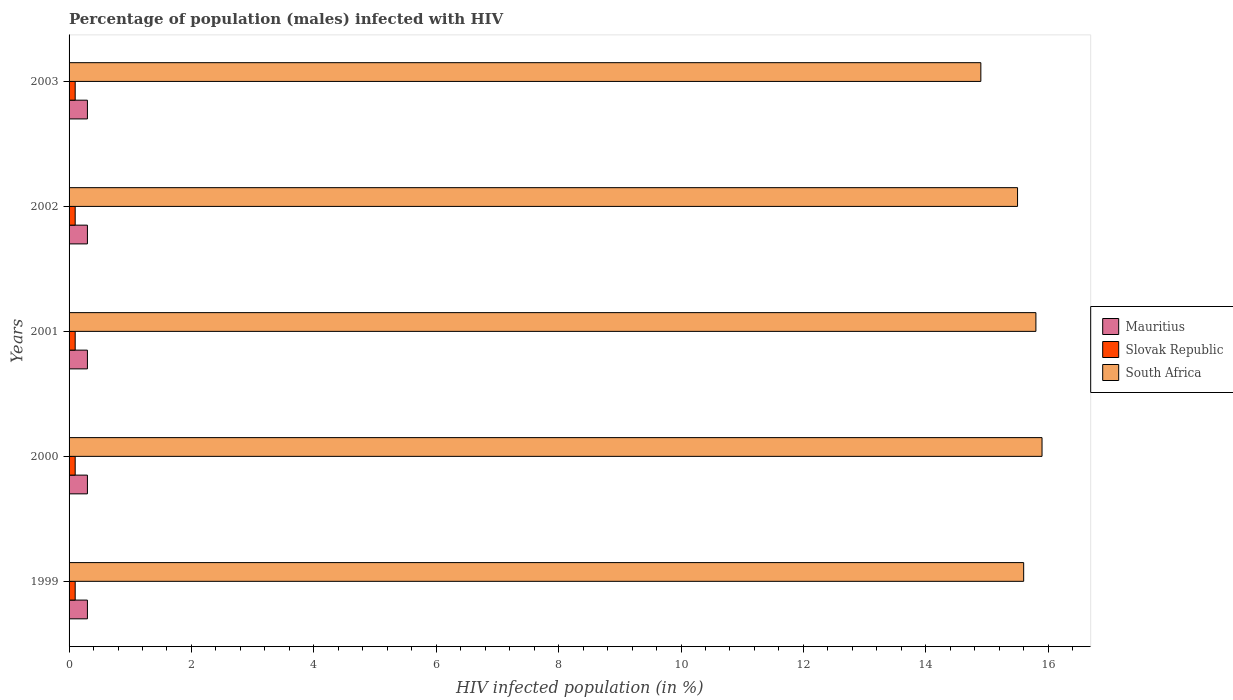Are the number of bars per tick equal to the number of legend labels?
Your answer should be very brief. Yes. What is the label of the 5th group of bars from the top?
Your response must be concise. 1999. What is the percentage of HIV infected male population in Mauritius in 2000?
Give a very brief answer. 0.3. Across all years, what is the maximum percentage of HIV infected male population in Mauritius?
Ensure brevity in your answer.  0.3. Across all years, what is the minimum percentage of HIV infected male population in Mauritius?
Your response must be concise. 0.3. In which year was the percentage of HIV infected male population in Slovak Republic minimum?
Keep it short and to the point. 1999. What is the total percentage of HIV infected male population in South Africa in the graph?
Offer a very short reply. 77.7. What is the difference between the percentage of HIV infected male population in South Africa in 2000 and the percentage of HIV infected male population in Mauritius in 2002?
Give a very brief answer. 15.6. What is the average percentage of HIV infected male population in South Africa per year?
Ensure brevity in your answer.  15.54. In the year 1999, what is the difference between the percentage of HIV infected male population in Slovak Republic and percentage of HIV infected male population in South Africa?
Offer a very short reply. -15.5. What is the ratio of the percentage of HIV infected male population in South Africa in 2000 to that in 2002?
Offer a terse response. 1.03. Is the percentage of HIV infected male population in Mauritius in 1999 less than that in 2001?
Ensure brevity in your answer.  No. Is the difference between the percentage of HIV infected male population in Slovak Republic in 2000 and 2003 greater than the difference between the percentage of HIV infected male population in South Africa in 2000 and 2003?
Ensure brevity in your answer.  No. What is the difference between the highest and the second highest percentage of HIV infected male population in South Africa?
Your response must be concise. 0.1. In how many years, is the percentage of HIV infected male population in Mauritius greater than the average percentage of HIV infected male population in Mauritius taken over all years?
Make the answer very short. 0. What does the 3rd bar from the top in 2000 represents?
Give a very brief answer. Mauritius. What does the 2nd bar from the bottom in 2001 represents?
Keep it short and to the point. Slovak Republic. How many years are there in the graph?
Your response must be concise. 5. What is the difference between two consecutive major ticks on the X-axis?
Keep it short and to the point. 2. Are the values on the major ticks of X-axis written in scientific E-notation?
Give a very brief answer. No. Does the graph contain grids?
Provide a succinct answer. No. What is the title of the graph?
Offer a terse response. Percentage of population (males) infected with HIV. Does "Philippines" appear as one of the legend labels in the graph?
Offer a terse response. No. What is the label or title of the X-axis?
Your answer should be compact. HIV infected population (in %). What is the HIV infected population (in %) of Slovak Republic in 1999?
Offer a very short reply. 0.1. What is the HIV infected population (in %) in South Africa in 1999?
Your answer should be compact. 15.6. What is the HIV infected population (in %) of South Africa in 2000?
Your answer should be very brief. 15.9. What is the HIV infected population (in %) of South Africa in 2001?
Your answer should be compact. 15.8. What is the HIV infected population (in %) in South Africa in 2002?
Offer a very short reply. 15.5. What is the HIV infected population (in %) of Mauritius in 2003?
Offer a very short reply. 0.3. What is the HIV infected population (in %) in South Africa in 2003?
Give a very brief answer. 14.9. Across all years, what is the maximum HIV infected population (in %) in Mauritius?
Ensure brevity in your answer.  0.3. Across all years, what is the maximum HIV infected population (in %) in Slovak Republic?
Keep it short and to the point. 0.1. Across all years, what is the minimum HIV infected population (in %) in Mauritius?
Offer a very short reply. 0.3. Across all years, what is the minimum HIV infected population (in %) in Slovak Republic?
Keep it short and to the point. 0.1. Across all years, what is the minimum HIV infected population (in %) in South Africa?
Provide a succinct answer. 14.9. What is the total HIV infected population (in %) in South Africa in the graph?
Give a very brief answer. 77.7. What is the difference between the HIV infected population (in %) in Mauritius in 1999 and that in 2000?
Make the answer very short. 0. What is the difference between the HIV infected population (in %) in South Africa in 1999 and that in 2000?
Provide a succinct answer. -0.3. What is the difference between the HIV infected population (in %) of Mauritius in 1999 and that in 2001?
Provide a short and direct response. 0. What is the difference between the HIV infected population (in %) in Slovak Republic in 1999 and that in 2001?
Offer a terse response. 0. What is the difference between the HIV infected population (in %) of South Africa in 1999 and that in 2001?
Make the answer very short. -0.2. What is the difference between the HIV infected population (in %) of Mauritius in 1999 and that in 2002?
Your answer should be very brief. 0. What is the difference between the HIV infected population (in %) of Slovak Republic in 1999 and that in 2002?
Give a very brief answer. 0. What is the difference between the HIV infected population (in %) of South Africa in 1999 and that in 2002?
Ensure brevity in your answer.  0.1. What is the difference between the HIV infected population (in %) in Slovak Republic in 2000 and that in 2001?
Offer a terse response. 0. What is the difference between the HIV infected population (in %) in Mauritius in 2000 and that in 2002?
Give a very brief answer. 0. What is the difference between the HIV infected population (in %) of Slovak Republic in 2000 and that in 2002?
Make the answer very short. 0. What is the difference between the HIV infected population (in %) of Mauritius in 2000 and that in 2003?
Offer a very short reply. 0. What is the difference between the HIV infected population (in %) in Slovak Republic in 2001 and that in 2002?
Make the answer very short. 0. What is the difference between the HIV infected population (in %) in Mauritius in 2001 and that in 2003?
Offer a terse response. 0. What is the difference between the HIV infected population (in %) in South Africa in 2001 and that in 2003?
Your response must be concise. 0.9. What is the difference between the HIV infected population (in %) of Slovak Republic in 2002 and that in 2003?
Make the answer very short. 0. What is the difference between the HIV infected population (in %) in Mauritius in 1999 and the HIV infected population (in %) in South Africa in 2000?
Keep it short and to the point. -15.6. What is the difference between the HIV infected population (in %) of Slovak Republic in 1999 and the HIV infected population (in %) of South Africa in 2000?
Keep it short and to the point. -15.8. What is the difference between the HIV infected population (in %) of Mauritius in 1999 and the HIV infected population (in %) of Slovak Republic in 2001?
Your response must be concise. 0.2. What is the difference between the HIV infected population (in %) in Mauritius in 1999 and the HIV infected population (in %) in South Africa in 2001?
Give a very brief answer. -15.5. What is the difference between the HIV infected population (in %) of Slovak Republic in 1999 and the HIV infected population (in %) of South Africa in 2001?
Provide a short and direct response. -15.7. What is the difference between the HIV infected population (in %) in Mauritius in 1999 and the HIV infected population (in %) in South Africa in 2002?
Ensure brevity in your answer.  -15.2. What is the difference between the HIV infected population (in %) in Slovak Republic in 1999 and the HIV infected population (in %) in South Africa in 2002?
Provide a short and direct response. -15.4. What is the difference between the HIV infected population (in %) in Mauritius in 1999 and the HIV infected population (in %) in South Africa in 2003?
Offer a terse response. -14.6. What is the difference between the HIV infected population (in %) in Slovak Republic in 1999 and the HIV infected population (in %) in South Africa in 2003?
Ensure brevity in your answer.  -14.8. What is the difference between the HIV infected population (in %) in Mauritius in 2000 and the HIV infected population (in %) in South Africa in 2001?
Give a very brief answer. -15.5. What is the difference between the HIV infected population (in %) in Slovak Republic in 2000 and the HIV infected population (in %) in South Africa in 2001?
Your answer should be compact. -15.7. What is the difference between the HIV infected population (in %) in Mauritius in 2000 and the HIV infected population (in %) in South Africa in 2002?
Provide a short and direct response. -15.2. What is the difference between the HIV infected population (in %) in Slovak Republic in 2000 and the HIV infected population (in %) in South Africa in 2002?
Your response must be concise. -15.4. What is the difference between the HIV infected population (in %) in Mauritius in 2000 and the HIV infected population (in %) in South Africa in 2003?
Offer a very short reply. -14.6. What is the difference between the HIV infected population (in %) in Slovak Republic in 2000 and the HIV infected population (in %) in South Africa in 2003?
Your response must be concise. -14.8. What is the difference between the HIV infected population (in %) in Mauritius in 2001 and the HIV infected population (in %) in Slovak Republic in 2002?
Offer a very short reply. 0.2. What is the difference between the HIV infected population (in %) of Mauritius in 2001 and the HIV infected population (in %) of South Africa in 2002?
Your response must be concise. -15.2. What is the difference between the HIV infected population (in %) of Slovak Republic in 2001 and the HIV infected population (in %) of South Africa in 2002?
Offer a terse response. -15.4. What is the difference between the HIV infected population (in %) of Mauritius in 2001 and the HIV infected population (in %) of Slovak Republic in 2003?
Give a very brief answer. 0.2. What is the difference between the HIV infected population (in %) in Mauritius in 2001 and the HIV infected population (in %) in South Africa in 2003?
Your answer should be compact. -14.6. What is the difference between the HIV infected population (in %) in Slovak Republic in 2001 and the HIV infected population (in %) in South Africa in 2003?
Provide a succinct answer. -14.8. What is the difference between the HIV infected population (in %) in Mauritius in 2002 and the HIV infected population (in %) in Slovak Republic in 2003?
Keep it short and to the point. 0.2. What is the difference between the HIV infected population (in %) in Mauritius in 2002 and the HIV infected population (in %) in South Africa in 2003?
Keep it short and to the point. -14.6. What is the difference between the HIV infected population (in %) of Slovak Republic in 2002 and the HIV infected population (in %) of South Africa in 2003?
Offer a terse response. -14.8. What is the average HIV infected population (in %) in Slovak Republic per year?
Make the answer very short. 0.1. What is the average HIV infected population (in %) of South Africa per year?
Your answer should be compact. 15.54. In the year 1999, what is the difference between the HIV infected population (in %) in Mauritius and HIV infected population (in %) in South Africa?
Your response must be concise. -15.3. In the year 1999, what is the difference between the HIV infected population (in %) in Slovak Republic and HIV infected population (in %) in South Africa?
Your answer should be compact. -15.5. In the year 2000, what is the difference between the HIV infected population (in %) of Mauritius and HIV infected population (in %) of South Africa?
Provide a succinct answer. -15.6. In the year 2000, what is the difference between the HIV infected population (in %) in Slovak Republic and HIV infected population (in %) in South Africa?
Make the answer very short. -15.8. In the year 2001, what is the difference between the HIV infected population (in %) of Mauritius and HIV infected population (in %) of South Africa?
Provide a succinct answer. -15.5. In the year 2001, what is the difference between the HIV infected population (in %) in Slovak Republic and HIV infected population (in %) in South Africa?
Your response must be concise. -15.7. In the year 2002, what is the difference between the HIV infected population (in %) in Mauritius and HIV infected population (in %) in Slovak Republic?
Provide a short and direct response. 0.2. In the year 2002, what is the difference between the HIV infected population (in %) of Mauritius and HIV infected population (in %) of South Africa?
Keep it short and to the point. -15.2. In the year 2002, what is the difference between the HIV infected population (in %) of Slovak Republic and HIV infected population (in %) of South Africa?
Provide a short and direct response. -15.4. In the year 2003, what is the difference between the HIV infected population (in %) of Mauritius and HIV infected population (in %) of South Africa?
Keep it short and to the point. -14.6. In the year 2003, what is the difference between the HIV infected population (in %) in Slovak Republic and HIV infected population (in %) in South Africa?
Your answer should be compact. -14.8. What is the ratio of the HIV infected population (in %) in Mauritius in 1999 to that in 2000?
Make the answer very short. 1. What is the ratio of the HIV infected population (in %) in South Africa in 1999 to that in 2000?
Provide a succinct answer. 0.98. What is the ratio of the HIV infected population (in %) of South Africa in 1999 to that in 2001?
Offer a very short reply. 0.99. What is the ratio of the HIV infected population (in %) of Mauritius in 1999 to that in 2002?
Offer a very short reply. 1. What is the ratio of the HIV infected population (in %) in South Africa in 1999 to that in 2002?
Your answer should be compact. 1.01. What is the ratio of the HIV infected population (in %) in Mauritius in 1999 to that in 2003?
Offer a very short reply. 1. What is the ratio of the HIV infected population (in %) in South Africa in 1999 to that in 2003?
Provide a short and direct response. 1.05. What is the ratio of the HIV infected population (in %) in Mauritius in 2000 to that in 2001?
Ensure brevity in your answer.  1. What is the ratio of the HIV infected population (in %) in Mauritius in 2000 to that in 2002?
Keep it short and to the point. 1. What is the ratio of the HIV infected population (in %) in Slovak Republic in 2000 to that in 2002?
Your answer should be compact. 1. What is the ratio of the HIV infected population (in %) of South Africa in 2000 to that in 2002?
Make the answer very short. 1.03. What is the ratio of the HIV infected population (in %) in South Africa in 2000 to that in 2003?
Offer a terse response. 1.07. What is the ratio of the HIV infected population (in %) of Slovak Republic in 2001 to that in 2002?
Your response must be concise. 1. What is the ratio of the HIV infected population (in %) of South Africa in 2001 to that in 2002?
Your response must be concise. 1.02. What is the ratio of the HIV infected population (in %) in Mauritius in 2001 to that in 2003?
Your response must be concise. 1. What is the ratio of the HIV infected population (in %) of South Africa in 2001 to that in 2003?
Your answer should be very brief. 1.06. What is the ratio of the HIV infected population (in %) in Mauritius in 2002 to that in 2003?
Provide a short and direct response. 1. What is the ratio of the HIV infected population (in %) of Slovak Republic in 2002 to that in 2003?
Your answer should be very brief. 1. What is the ratio of the HIV infected population (in %) of South Africa in 2002 to that in 2003?
Provide a short and direct response. 1.04. What is the difference between the highest and the second highest HIV infected population (in %) of Mauritius?
Provide a short and direct response. 0. What is the difference between the highest and the second highest HIV infected population (in %) in South Africa?
Give a very brief answer. 0.1. What is the difference between the highest and the lowest HIV infected population (in %) of Mauritius?
Your answer should be compact. 0. What is the difference between the highest and the lowest HIV infected population (in %) of Slovak Republic?
Keep it short and to the point. 0. 